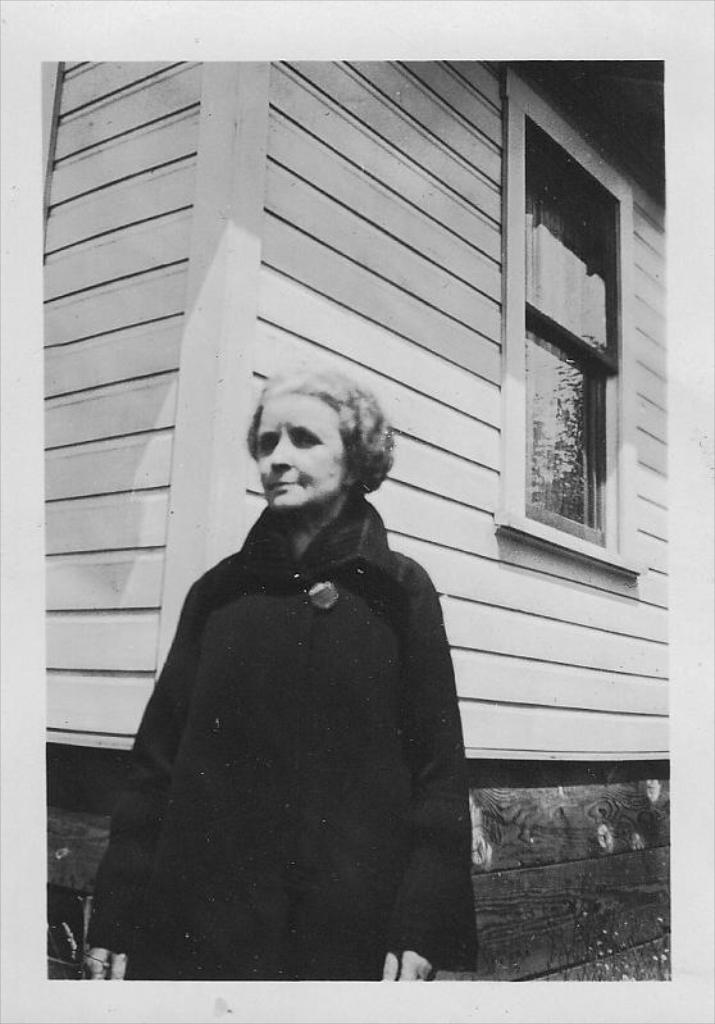What is the color scheme of the image? The image is black and white. What can be seen in the foreground of the image? There is a lady standing in the image. What is the lady wearing? The lady is wearing a coat. What can be seen in the background of the image? There is a shed and a window visible in the background. What type of engine is powering the lady's movements in the image? There is no engine present in the image, and the lady's movements are not powered by any engine. What is the magic spell that the lady is casting in the image? There is no magic spell being cast in the image; the lady is simply standing. 